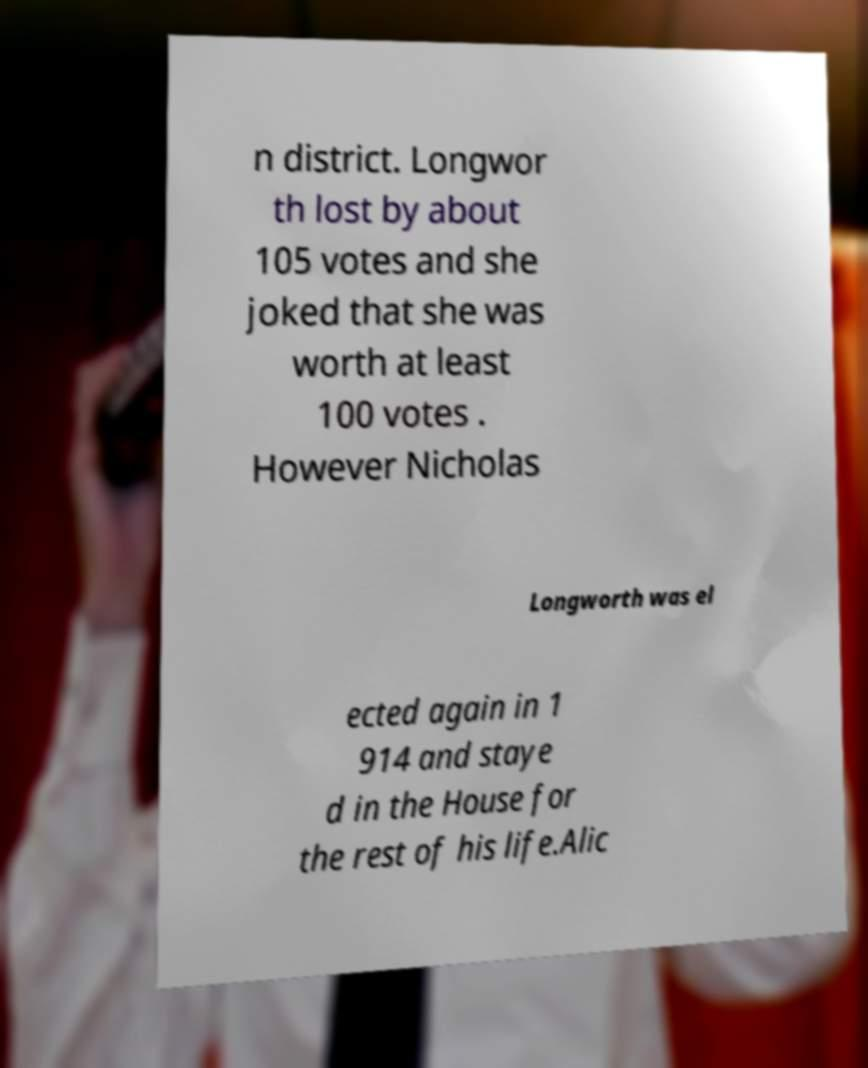Please identify and transcribe the text found in this image. n district. Longwor th lost by about 105 votes and she joked that she was worth at least 100 votes . However Nicholas Longworth was el ected again in 1 914 and staye d in the House for the rest of his life.Alic 